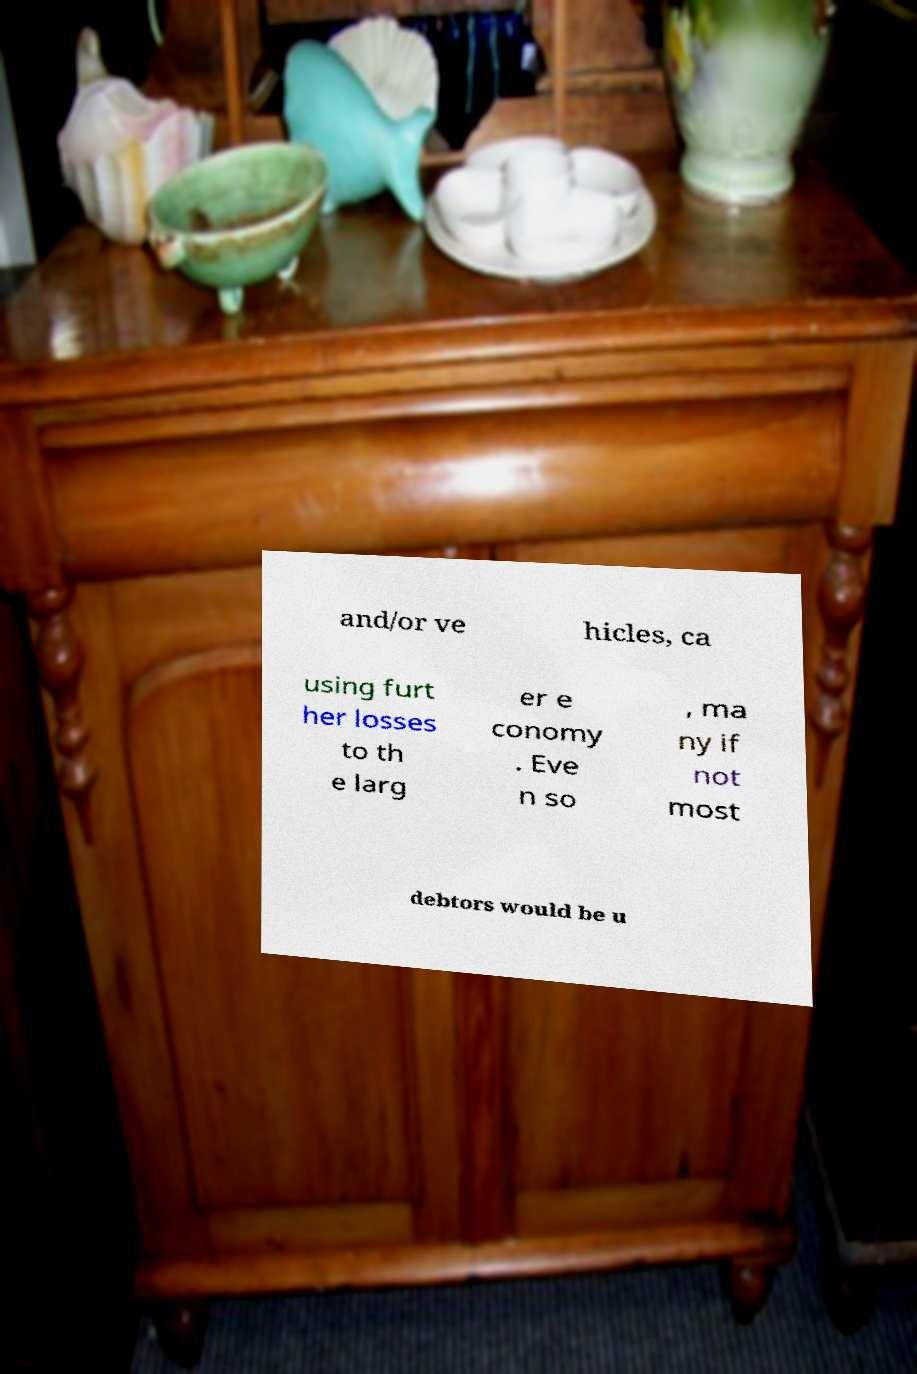What messages or text are displayed in this image? I need them in a readable, typed format. and/or ve hicles, ca using furt her losses to th e larg er e conomy . Eve n so , ma ny if not most debtors would be u 